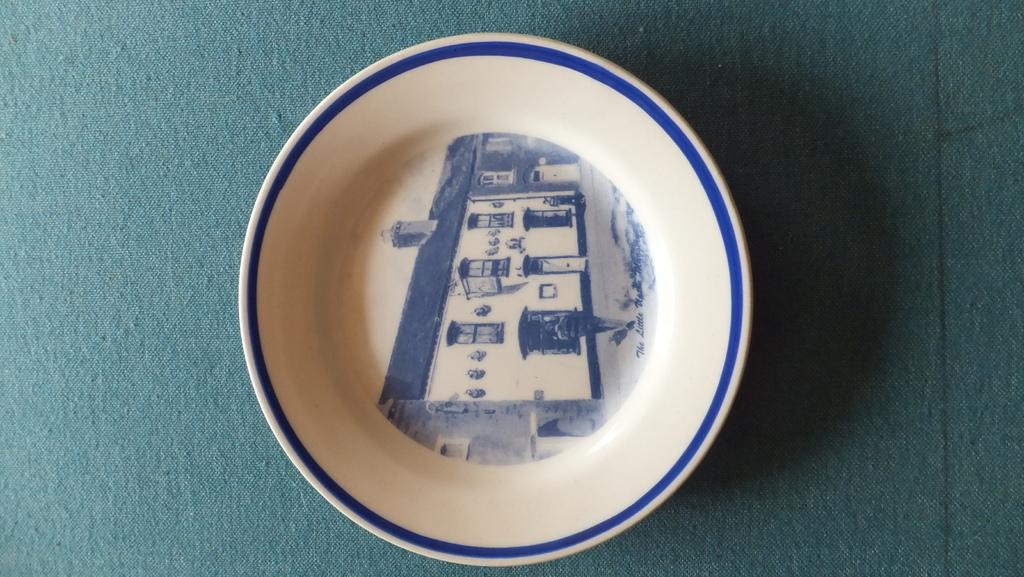What is on the plate that is visible in the image? There is an art piece on the plate in the image. What color is the plate? The plate is white. What can be seen in the background of the image? There is a green color thing in the background of the image. Can you hear the father coughing in the image? There is no reference to a father or any sounds in the image, so it's not possible to determine if someone is coughing. 